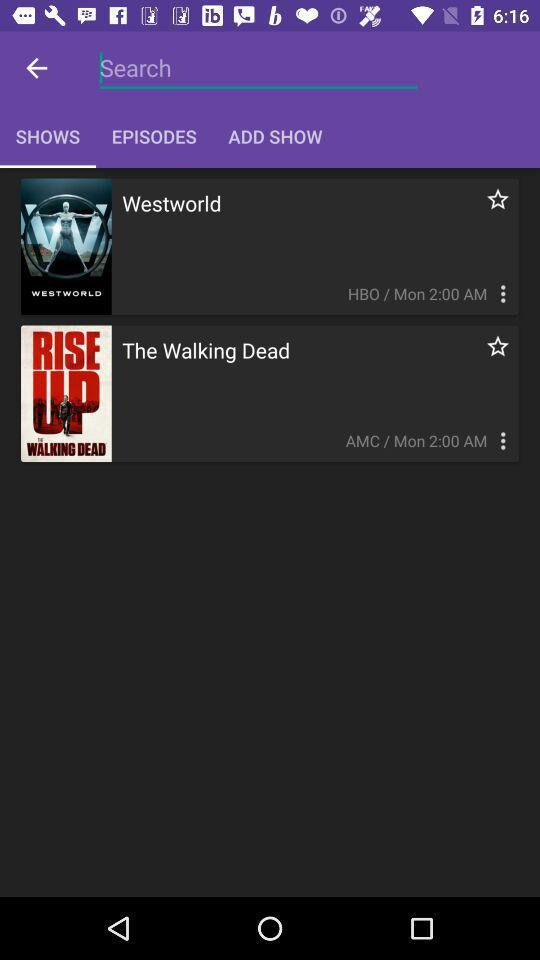What is the broadcast time of the walking dead? The broadcast time is Monday, 2:00 AM. 